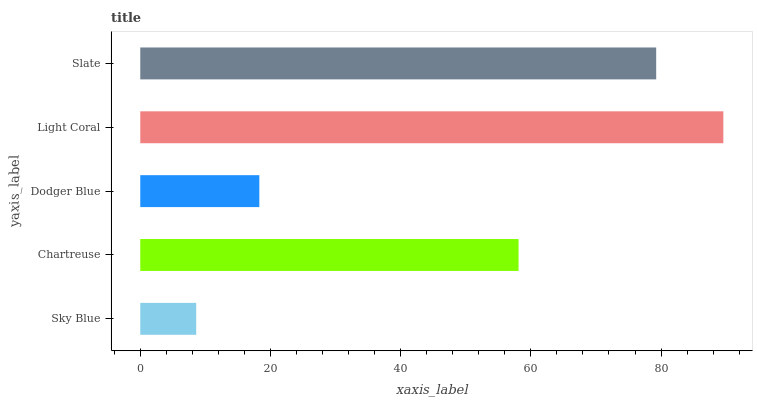Is Sky Blue the minimum?
Answer yes or no. Yes. Is Light Coral the maximum?
Answer yes or no. Yes. Is Chartreuse the minimum?
Answer yes or no. No. Is Chartreuse the maximum?
Answer yes or no. No. Is Chartreuse greater than Sky Blue?
Answer yes or no. Yes. Is Sky Blue less than Chartreuse?
Answer yes or no. Yes. Is Sky Blue greater than Chartreuse?
Answer yes or no. No. Is Chartreuse less than Sky Blue?
Answer yes or no. No. Is Chartreuse the high median?
Answer yes or no. Yes. Is Chartreuse the low median?
Answer yes or no. Yes. Is Slate the high median?
Answer yes or no. No. Is Slate the low median?
Answer yes or no. No. 